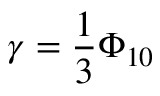Convert formula to latex. <formula><loc_0><loc_0><loc_500><loc_500>\gamma = \frac { 1 } { 3 } \Phi _ { 1 0 }</formula> 